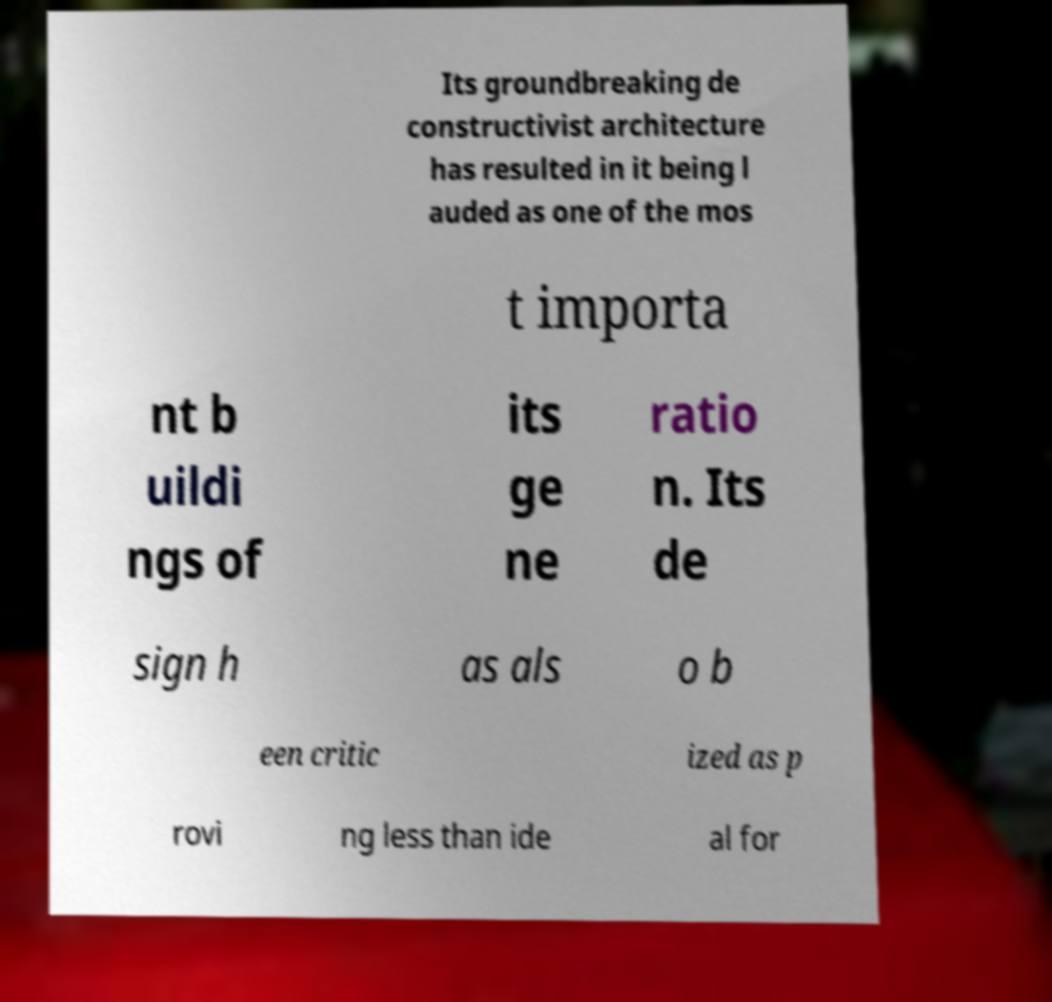Could you extract and type out the text from this image? Its groundbreaking de constructivist architecture has resulted in it being l auded as one of the mos t importa nt b uildi ngs of its ge ne ratio n. Its de sign h as als o b een critic ized as p rovi ng less than ide al for 